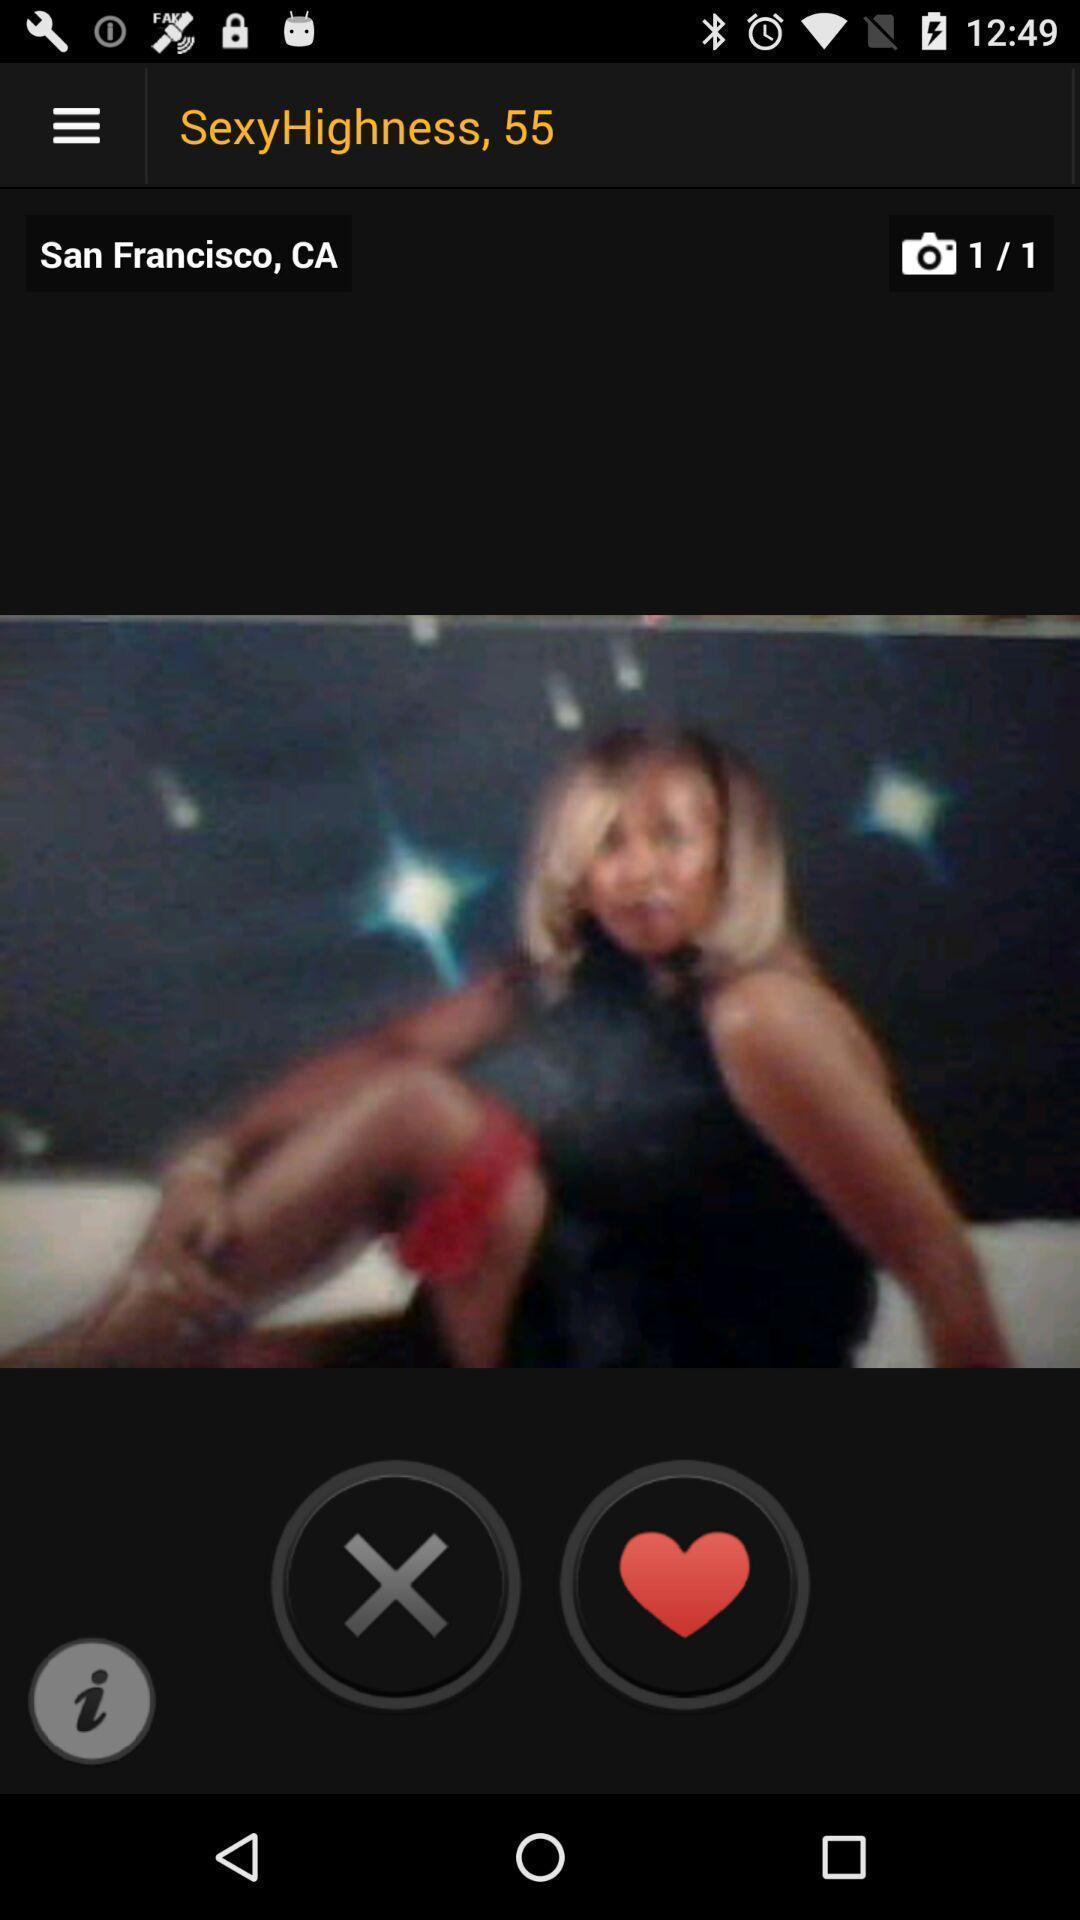Provide a description of this screenshot. Screen displaying a blur image. 